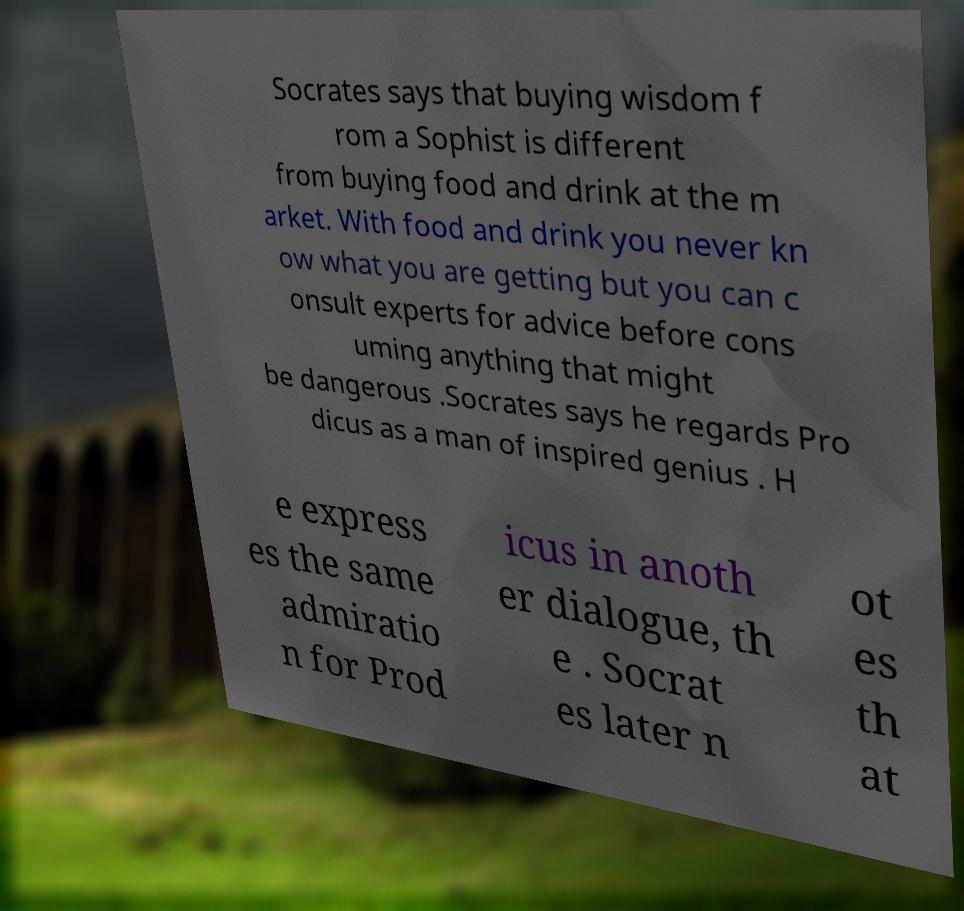Please read and relay the text visible in this image. What does it say? Socrates says that buying wisdom f rom a Sophist is different from buying food and drink at the m arket. With food and drink you never kn ow what you are getting but you can c onsult experts for advice before cons uming anything that might be dangerous .Socrates says he regards Pro dicus as a man of inspired genius . H e express es the same admiratio n for Prod icus in anoth er dialogue, th e . Socrat es later n ot es th at 